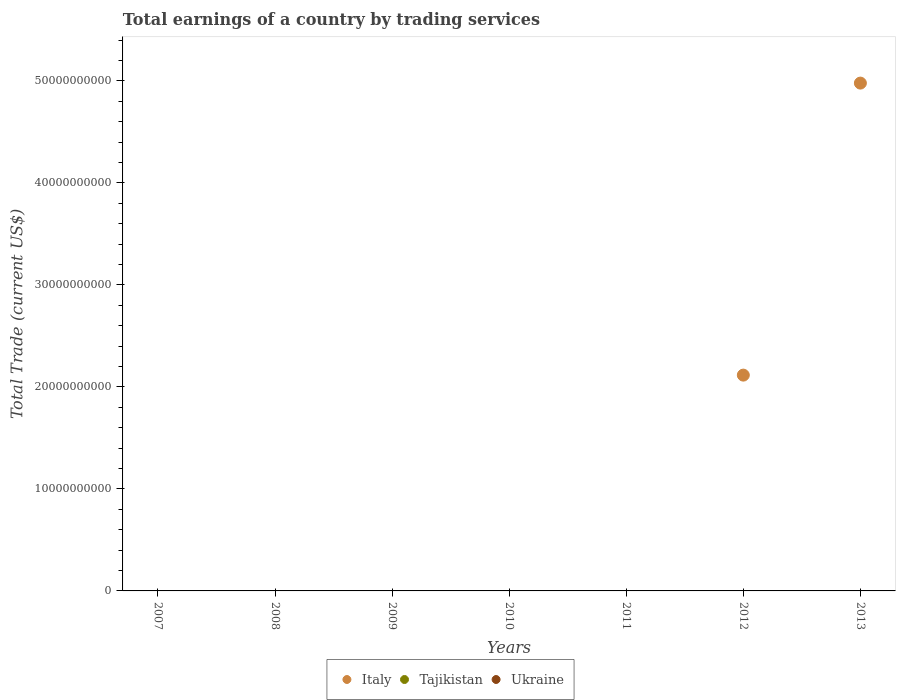Is the number of dotlines equal to the number of legend labels?
Give a very brief answer. No. What is the total earnings in Italy in 2011?
Your response must be concise. 0. Across all years, what is the maximum total earnings in Italy?
Your response must be concise. 4.98e+1. Across all years, what is the minimum total earnings in Tajikistan?
Keep it short and to the point. 0. What is the total total earnings in Tajikistan in the graph?
Your answer should be very brief. 0. What is the difference between the total earnings in Ukraine in 2010 and the total earnings in Tajikistan in 2007?
Your response must be concise. 0. What is the average total earnings in Tajikistan per year?
Make the answer very short. 0. What is the difference between the highest and the lowest total earnings in Italy?
Offer a very short reply. 4.98e+1. In how many years, is the total earnings in Tajikistan greater than the average total earnings in Tajikistan taken over all years?
Offer a terse response. 0. Is the sum of the total earnings in Italy in 2012 and 2013 greater than the maximum total earnings in Ukraine across all years?
Your answer should be very brief. Yes. Is the total earnings in Tajikistan strictly greater than the total earnings in Ukraine over the years?
Give a very brief answer. Yes. How many years are there in the graph?
Give a very brief answer. 7. Are the values on the major ticks of Y-axis written in scientific E-notation?
Provide a short and direct response. No. Does the graph contain grids?
Your response must be concise. No. How many legend labels are there?
Give a very brief answer. 3. How are the legend labels stacked?
Make the answer very short. Horizontal. What is the title of the graph?
Offer a terse response. Total earnings of a country by trading services. What is the label or title of the Y-axis?
Provide a succinct answer. Total Trade (current US$). What is the Total Trade (current US$) of Italy in 2007?
Your response must be concise. 0. What is the Total Trade (current US$) in Ukraine in 2007?
Offer a very short reply. 0. What is the Total Trade (current US$) of Tajikistan in 2008?
Your answer should be compact. 0. What is the Total Trade (current US$) in Italy in 2009?
Keep it short and to the point. 0. What is the Total Trade (current US$) of Tajikistan in 2009?
Ensure brevity in your answer.  0. What is the Total Trade (current US$) in Ukraine in 2009?
Give a very brief answer. 0. What is the Total Trade (current US$) in Ukraine in 2010?
Offer a very short reply. 0. What is the Total Trade (current US$) of Tajikistan in 2011?
Offer a very short reply. 0. What is the Total Trade (current US$) of Italy in 2012?
Offer a terse response. 2.12e+1. What is the Total Trade (current US$) of Tajikistan in 2012?
Offer a very short reply. 0. What is the Total Trade (current US$) in Ukraine in 2012?
Make the answer very short. 0. What is the Total Trade (current US$) of Italy in 2013?
Give a very brief answer. 4.98e+1. What is the Total Trade (current US$) in Tajikistan in 2013?
Your answer should be very brief. 0. What is the Total Trade (current US$) of Ukraine in 2013?
Keep it short and to the point. 0. Across all years, what is the maximum Total Trade (current US$) of Italy?
Your answer should be compact. 4.98e+1. What is the total Total Trade (current US$) in Italy in the graph?
Provide a short and direct response. 7.10e+1. What is the total Total Trade (current US$) of Tajikistan in the graph?
Provide a succinct answer. 0. What is the difference between the Total Trade (current US$) of Italy in 2012 and that in 2013?
Your response must be concise. -2.86e+1. What is the average Total Trade (current US$) in Italy per year?
Offer a very short reply. 1.01e+1. What is the average Total Trade (current US$) in Tajikistan per year?
Keep it short and to the point. 0. What is the ratio of the Total Trade (current US$) in Italy in 2012 to that in 2013?
Ensure brevity in your answer.  0.42. What is the difference between the highest and the lowest Total Trade (current US$) in Italy?
Offer a very short reply. 4.98e+1. 